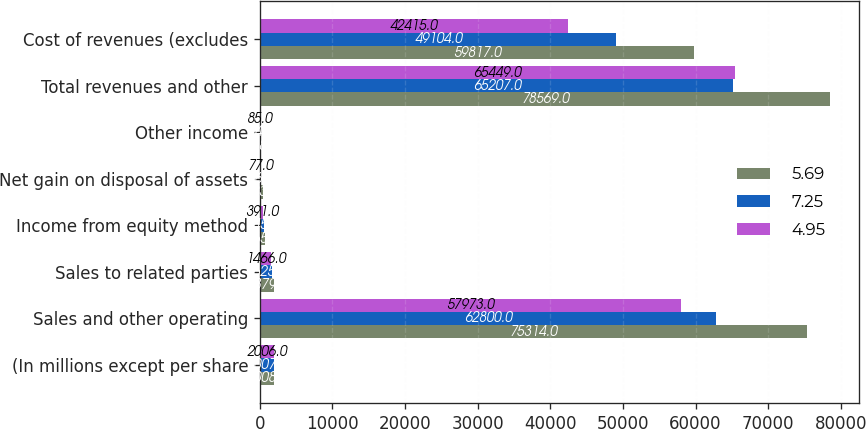Convert chart to OTSL. <chart><loc_0><loc_0><loc_500><loc_500><stacked_bar_chart><ecel><fcel>(In millions except per share<fcel>Sales and other operating<fcel>Sales to related parties<fcel>Income from equity method<fcel>Net gain on disposal of assets<fcel>Other income<fcel>Total revenues and other<fcel>Cost of revenues (excludes<nl><fcel>5.69<fcel>2008<fcel>75314<fcel>1879<fcel>765<fcel>423<fcel>188<fcel>78569<fcel>59817<nl><fcel>7.25<fcel>2007<fcel>62800<fcel>1625<fcel>545<fcel>36<fcel>74<fcel>65207<fcel>49104<nl><fcel>4.95<fcel>2006<fcel>57973<fcel>1466<fcel>391<fcel>77<fcel>85<fcel>65449<fcel>42415<nl></chart> 